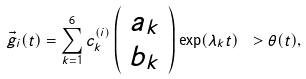<formula> <loc_0><loc_0><loc_500><loc_500>\vec { g } _ { i } ( t ) = \sum _ { k = 1 } ^ { 6 } c _ { k } ^ { ( i ) } \left ( \begin{array} { c } a _ { k } \\ b _ { k } \end{array} \right ) \exp ( \lambda _ { k } t ) \ > \theta ( t ) ,</formula> 